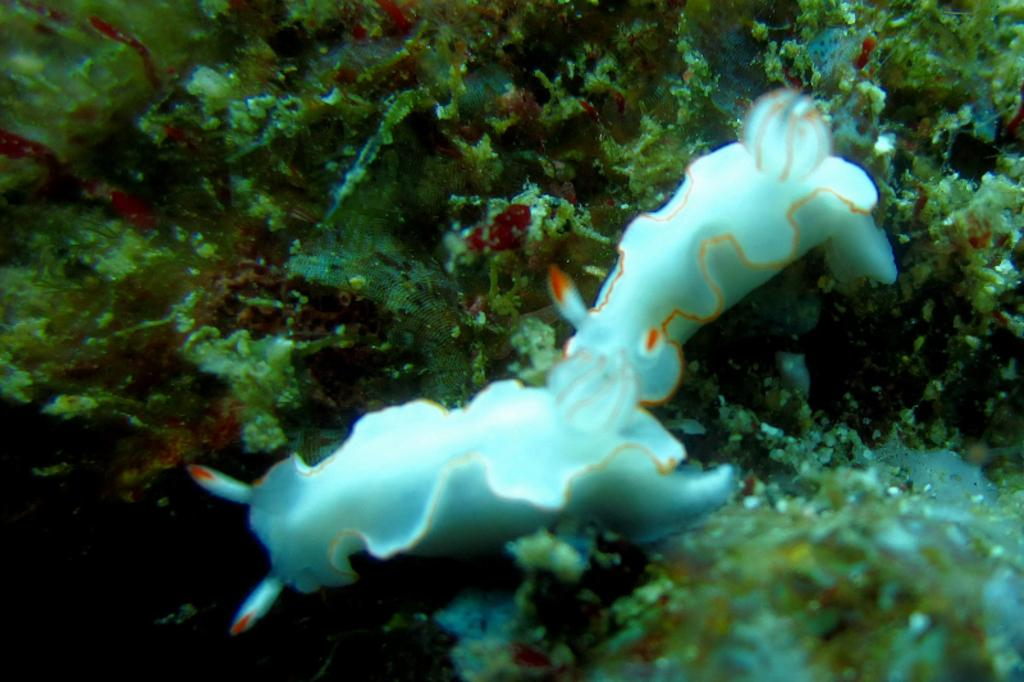What type of animal is present in the image? There is a water animal in the image. What can be seen growing in the water in the image? There is algae in the image. Can you describe the environment in which the image was taken? The image was taken in water. How many patches are visible on the water animal in the image? There is no reference to patches on the water animal in the image. What level of experience does the beginner have with the water animal in the image? There is no indication of any experience levels or individuals interacting with the water animal in the image. 